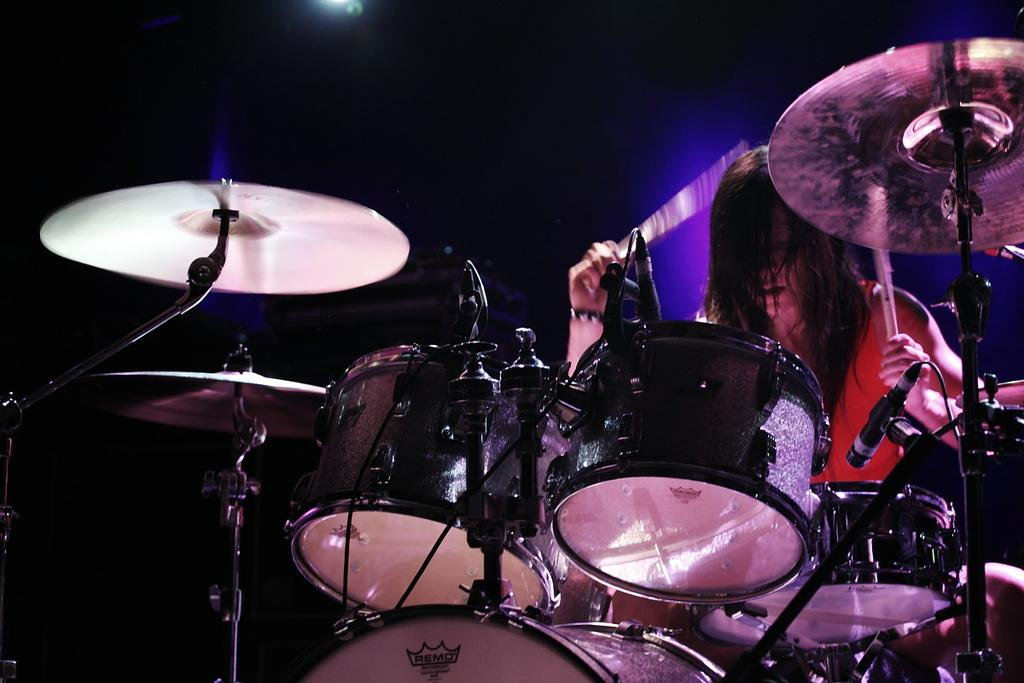What is the main activity being performed in the image? There is a person playing drums in the image. What objects are present that might be used for amplifying sound? There are microphones (mics) in the image. How would you describe the lighting conditions in the image? The background of the image is dark. What type of pleasure can be seen enjoying a loaf of bread in the image? There is no pleasure or loaf of bread present in the image; it features a person playing drums and microphones. 